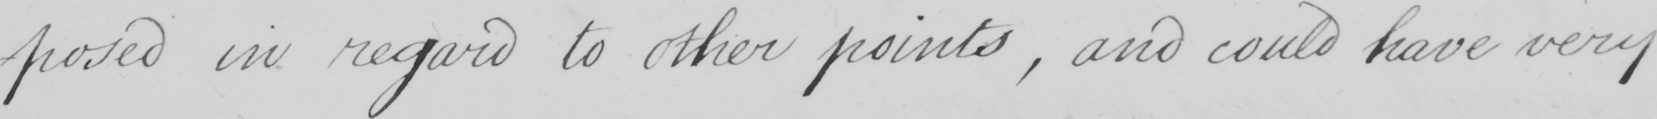Please provide the text content of this handwritten line. -posed in regard to other points , and could have very 